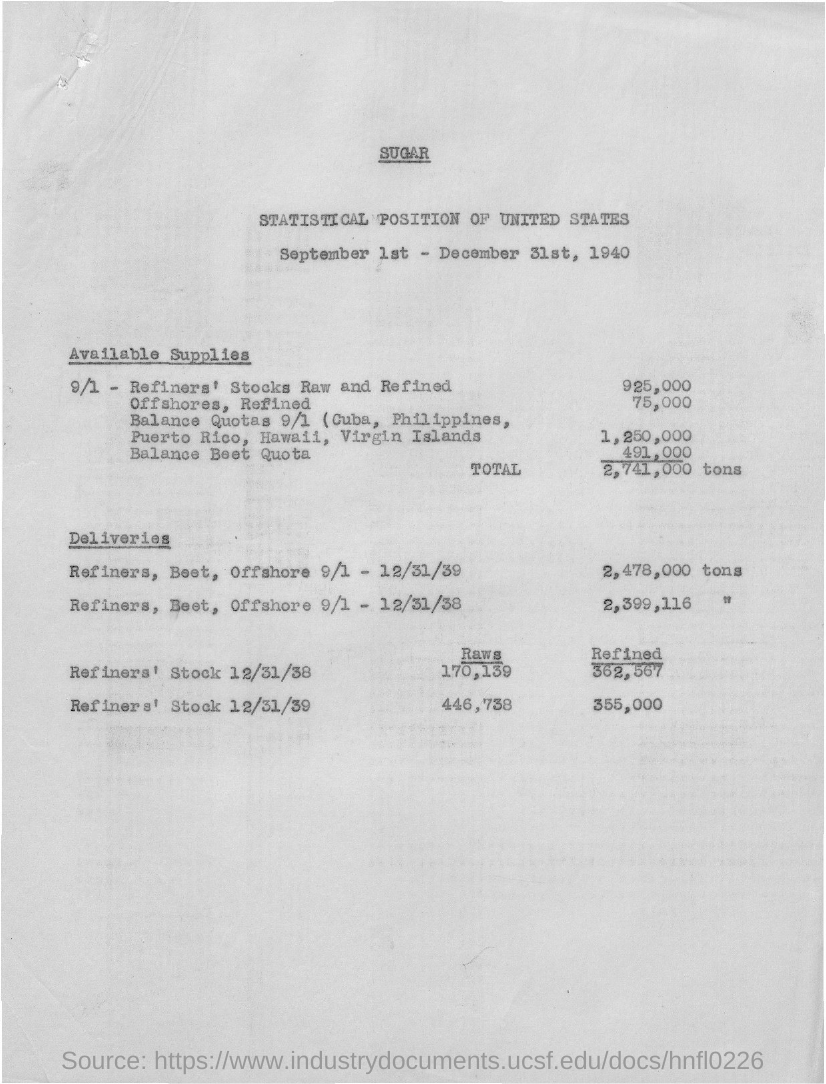Specify some key components in this picture. During the period of 9/1/39 to 12/31/39, a total of 2,478,000 tons of refiners were produced, including beet and offshore refiners. As of December 31, 1939, the refined refiner's stock was 355,000. The raw refiner's stock as of December 31, 1939, was 446,738. As of December 31st, 1938, the refined refiner's stock was 362,567. The refiner's stock as of December 31, 1938, was 170,139. 